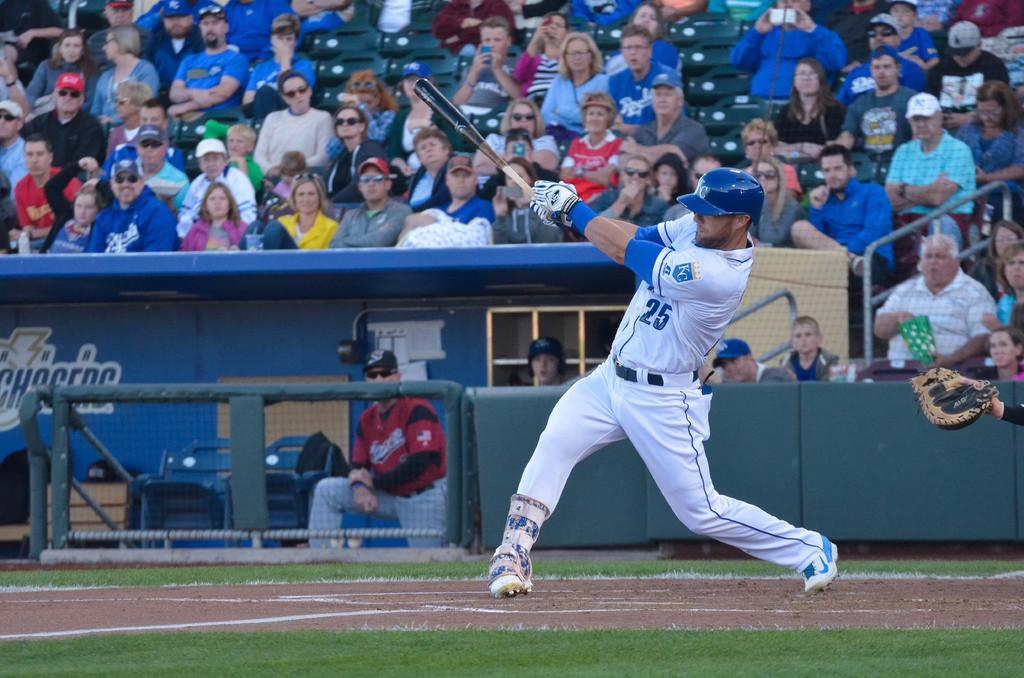<image>
Provide a brief description of the given image. A Kansas City Royals player wearing number 25 hits a baseball. 